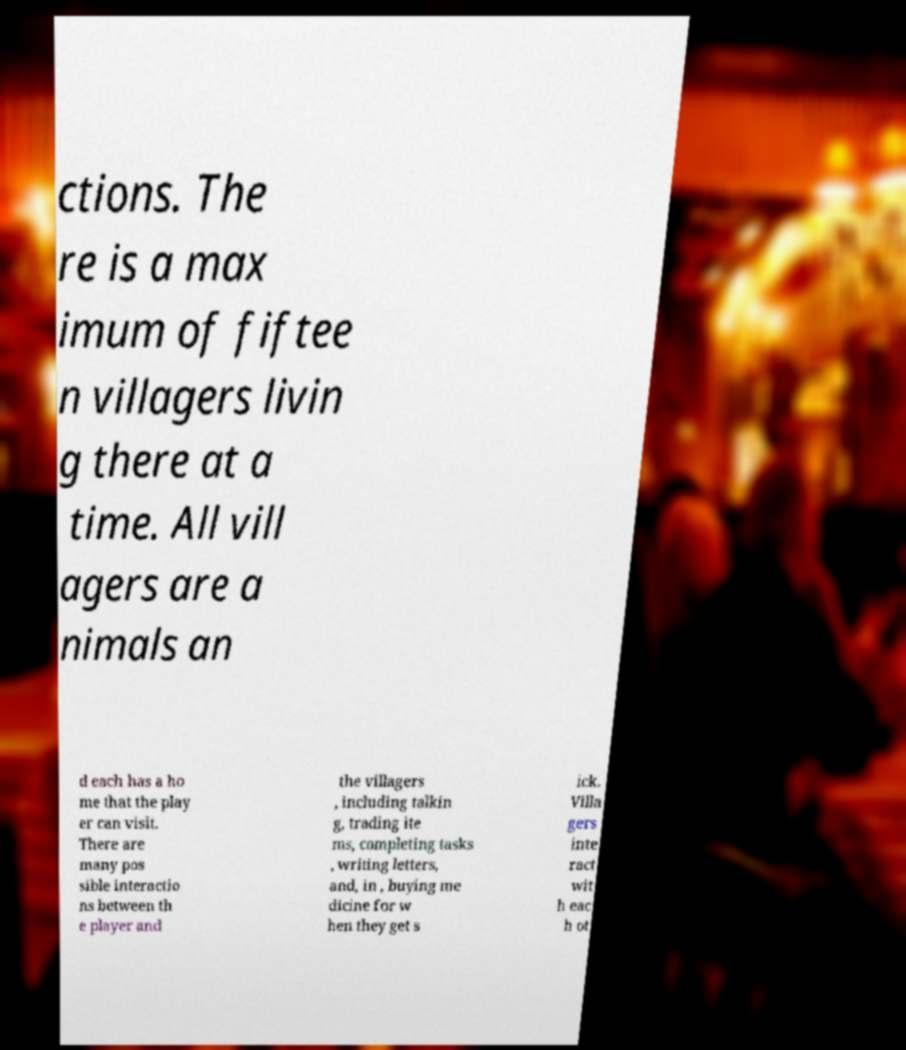Please read and relay the text visible in this image. What does it say? ctions. The re is a max imum of fiftee n villagers livin g there at a time. All vill agers are a nimals an d each has a ho me that the play er can visit. There are many pos sible interactio ns between th e player and the villagers , including talkin g, trading ite ms, completing tasks , writing letters, and, in , buying me dicine for w hen they get s ick. Villa gers inte ract wit h eac h ot 